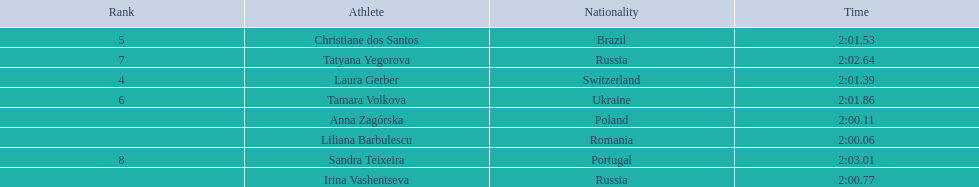What were all the finishing times? 2:00.06, 2:00.11, 2:00.77, 2:01.39, 2:01.53, 2:01.86, 2:02.64, 2:03.01. Which of these is anna zagorska's? 2:00.11. 